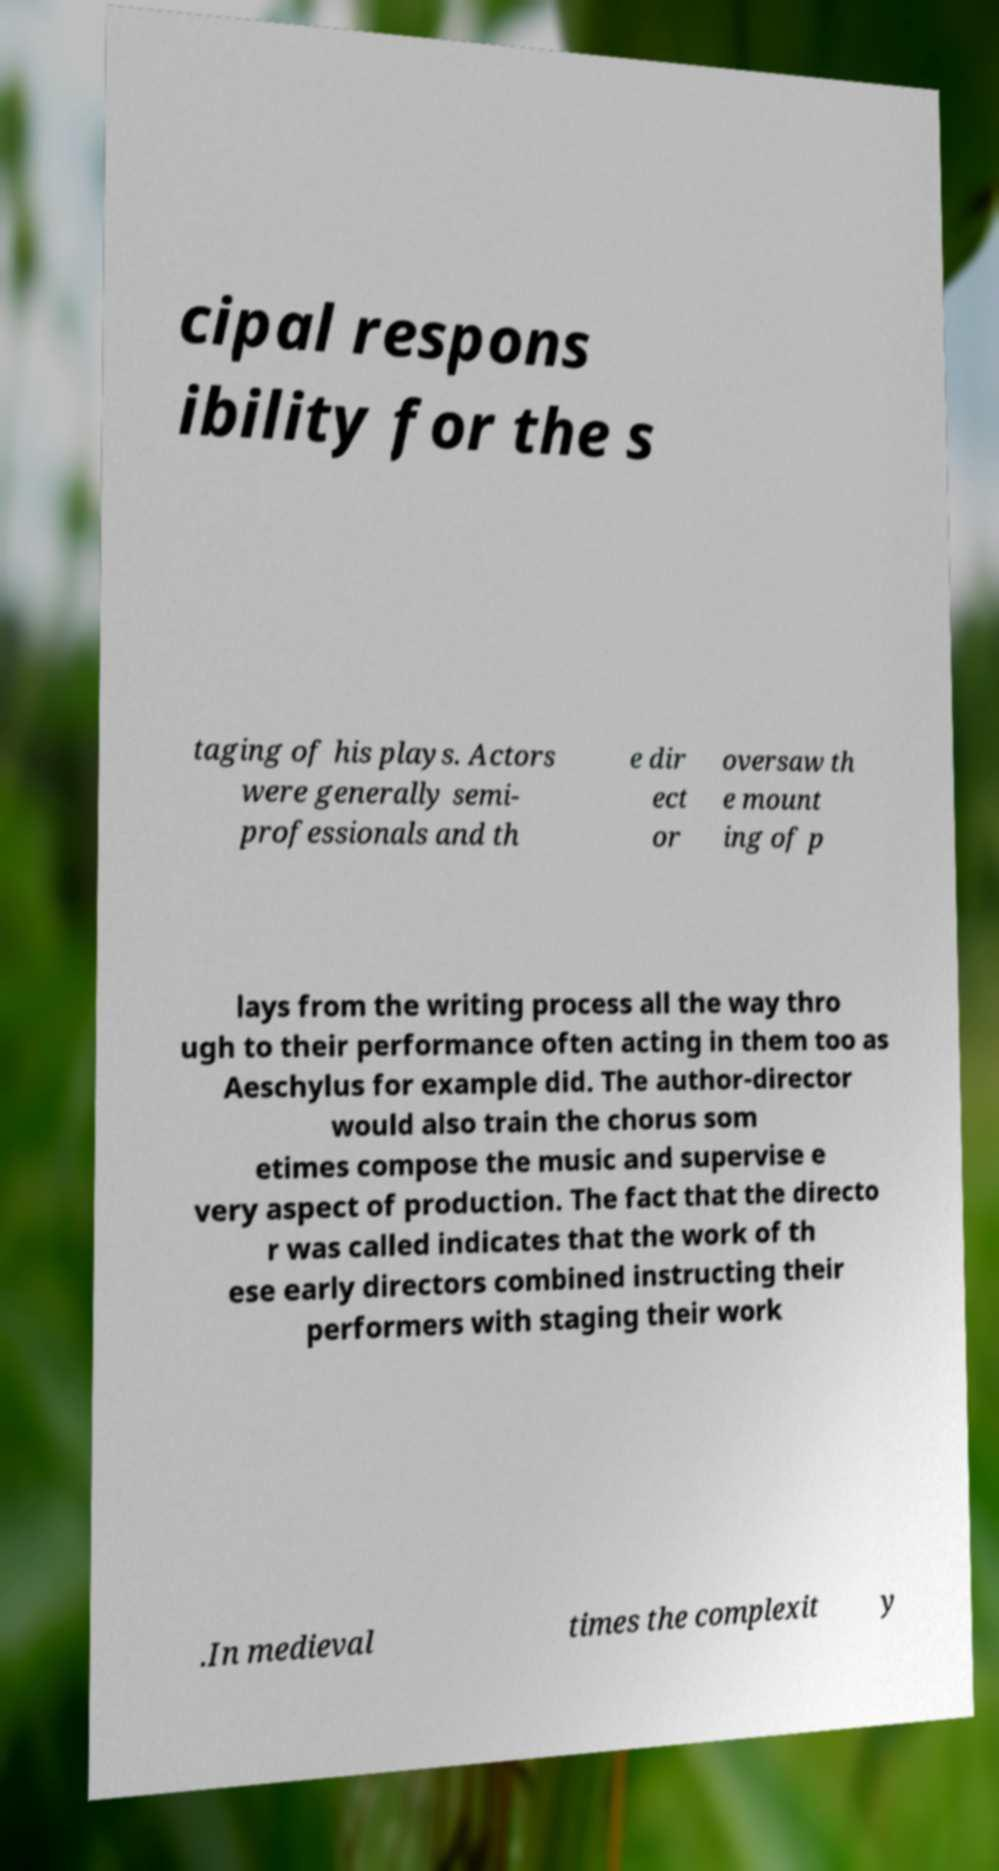Could you extract and type out the text from this image? cipal respons ibility for the s taging of his plays. Actors were generally semi- professionals and th e dir ect or oversaw th e mount ing of p lays from the writing process all the way thro ugh to their performance often acting in them too as Aeschylus for example did. The author-director would also train the chorus som etimes compose the music and supervise e very aspect of production. The fact that the directo r was called indicates that the work of th ese early directors combined instructing their performers with staging their work .In medieval times the complexit y 